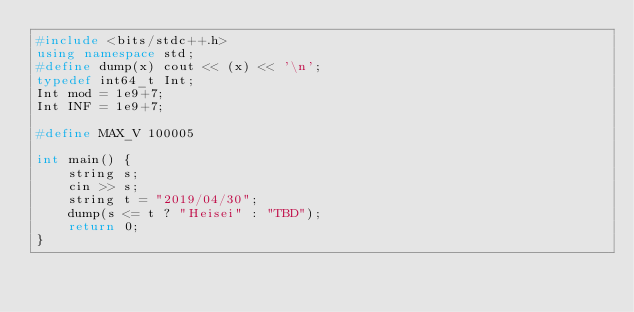Convert code to text. <code><loc_0><loc_0><loc_500><loc_500><_C++_>#include <bits/stdc++.h>
using namespace std;
#define dump(x) cout << (x) << '\n';
typedef int64_t Int;
Int mod = 1e9+7;
Int INF = 1e9+7;

#define MAX_V 100005

int main() {
    string s;
    cin >> s;
    string t = "2019/04/30";
    dump(s <= t ? "Heisei" : "TBD");
    return 0;
}</code> 